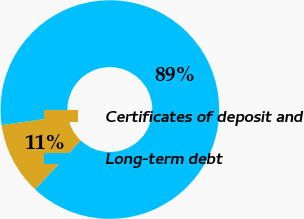<chart> <loc_0><loc_0><loc_500><loc_500><pie_chart><fcel>Certificates of deposit and<fcel>Long-term debt<nl><fcel>10.76%<fcel>89.24%<nl></chart> 